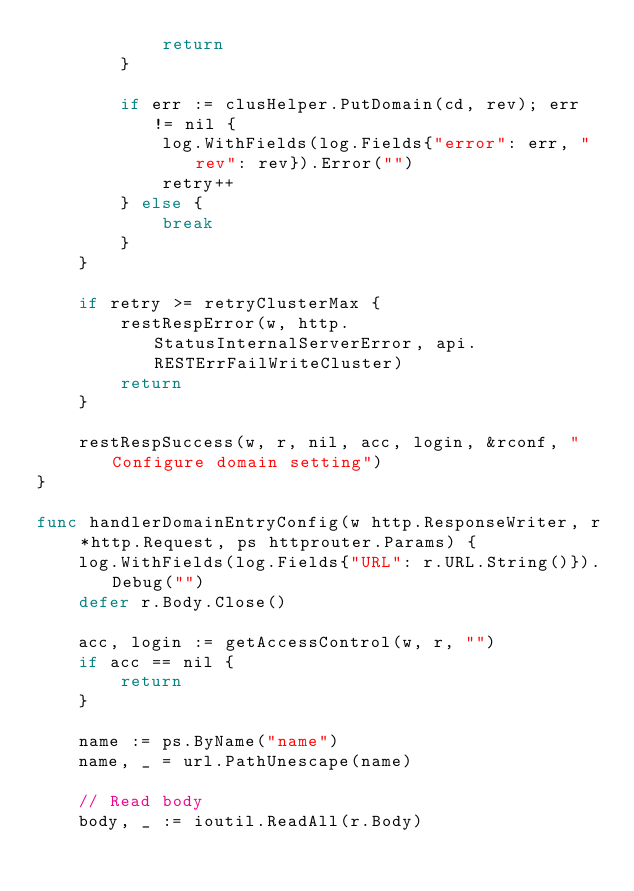<code> <loc_0><loc_0><loc_500><loc_500><_Go_>			return
		}

		if err := clusHelper.PutDomain(cd, rev); err != nil {
			log.WithFields(log.Fields{"error": err, "rev": rev}).Error("")
			retry++
		} else {
			break
		}
	}

	if retry >= retryClusterMax {
		restRespError(w, http.StatusInternalServerError, api.RESTErrFailWriteCluster)
		return
	}

	restRespSuccess(w, r, nil, acc, login, &rconf, "Configure domain setting")
}

func handlerDomainEntryConfig(w http.ResponseWriter, r *http.Request, ps httprouter.Params) {
	log.WithFields(log.Fields{"URL": r.URL.String()}).Debug("")
	defer r.Body.Close()

	acc, login := getAccessControl(w, r, "")
	if acc == nil {
		return
	}

	name := ps.ByName("name")
	name, _ = url.PathUnescape(name)

	// Read body
	body, _ := ioutil.ReadAll(r.Body)
</code> 